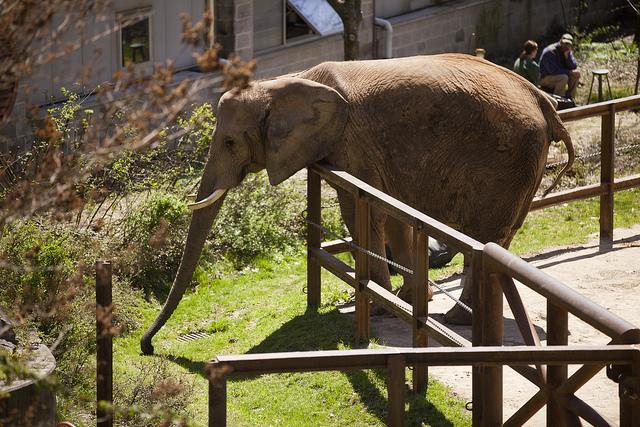What is the elephant standing behind?
Keep it brief. Fence. What color is the elephant?
Give a very brief answer. Brown. Does the elephant look happy?
Concise answer only. No. Do you think these animals like getting wet?
Answer briefly. Yes. Is he in a zoo?
Short answer required. Yes. How many animals are there?
Answer briefly. 1. Is this elephant in a zoo?
Give a very brief answer. Yes. 